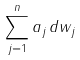<formula> <loc_0><loc_0><loc_500><loc_500>\sum _ { j = 1 } ^ { n } a _ { j } \, d w _ { j }</formula> 